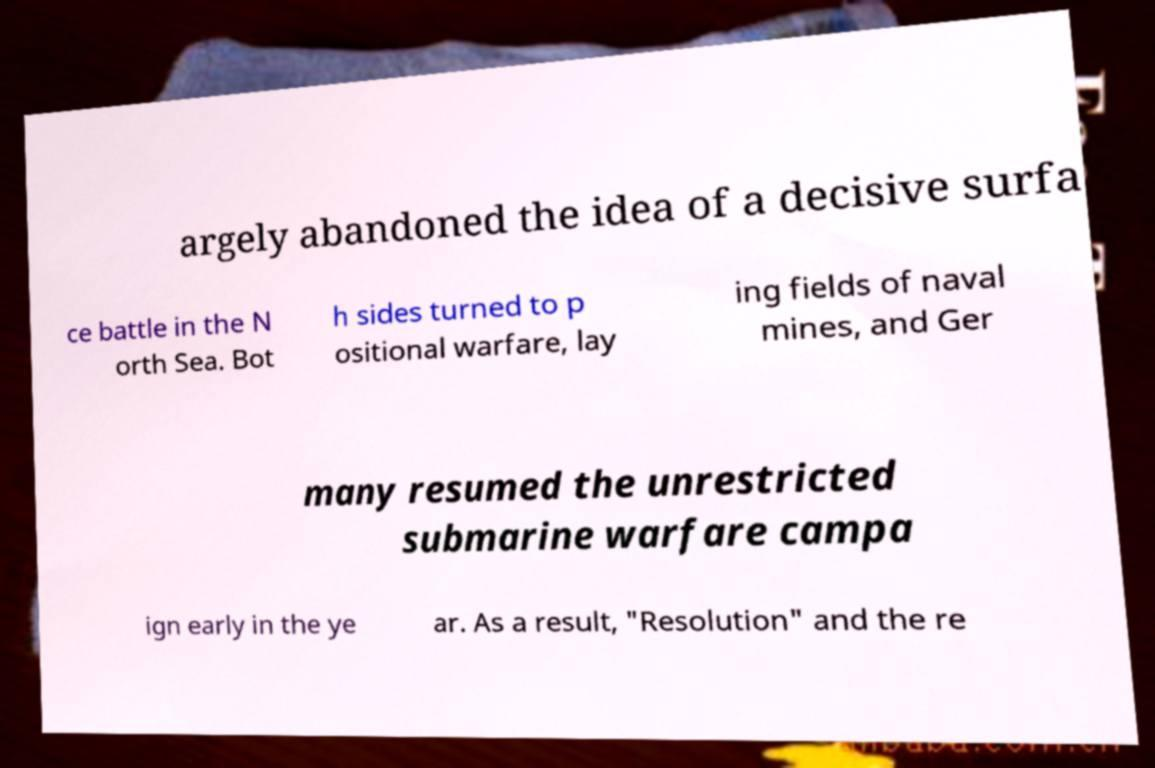What messages or text are displayed in this image? I need them in a readable, typed format. argely abandoned the idea of a decisive surfa ce battle in the N orth Sea. Bot h sides turned to p ositional warfare, lay ing fields of naval mines, and Ger many resumed the unrestricted submarine warfare campa ign early in the ye ar. As a result, "Resolution" and the re 